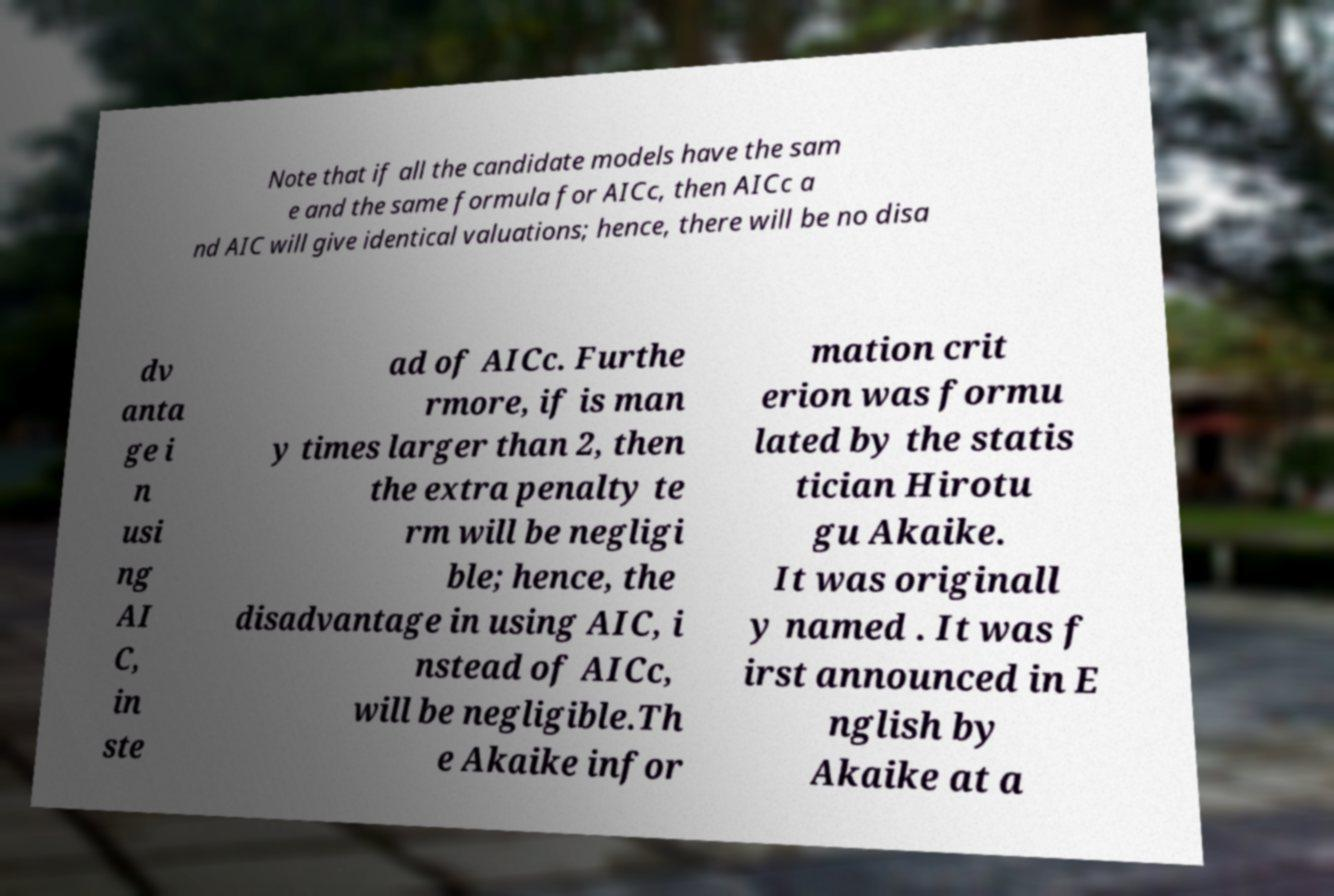For documentation purposes, I need the text within this image transcribed. Could you provide that? Note that if all the candidate models have the sam e and the same formula for AICc, then AICc a nd AIC will give identical valuations; hence, there will be no disa dv anta ge i n usi ng AI C, in ste ad of AICc. Furthe rmore, if is man y times larger than 2, then the extra penalty te rm will be negligi ble; hence, the disadvantage in using AIC, i nstead of AICc, will be negligible.Th e Akaike infor mation crit erion was formu lated by the statis tician Hirotu gu Akaike. It was originall y named . It was f irst announced in E nglish by Akaike at a 